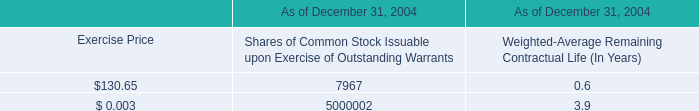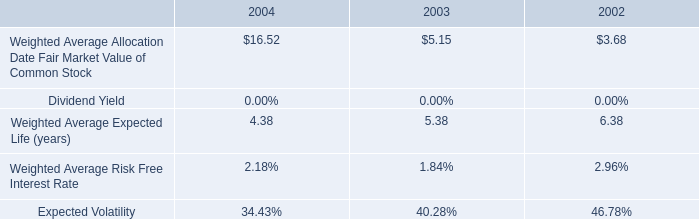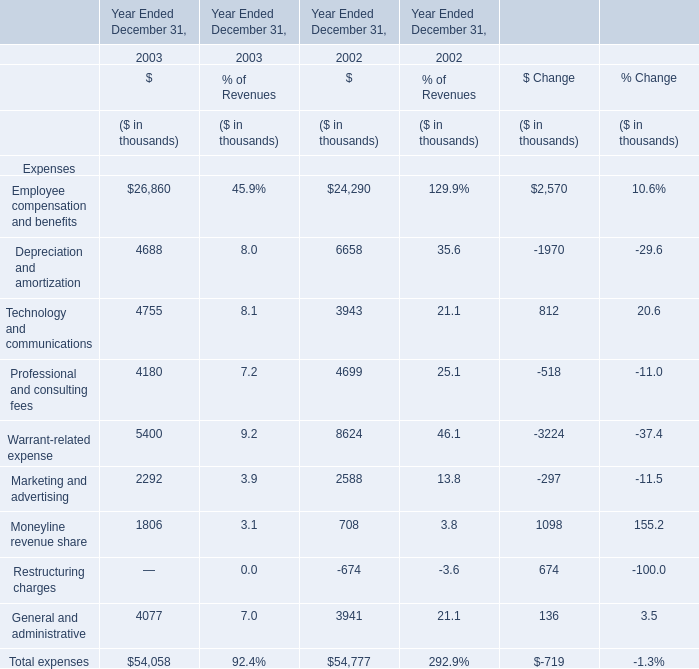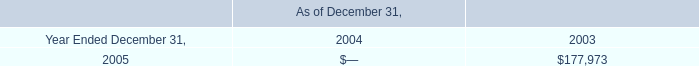What was the average value of Technology and communications, Professional and consulting fees, Warrant-related expense in 2002? (in thousand) 
Computations: (((3943 + 4699) + 8624) / 3)
Answer: 5755.33333. 